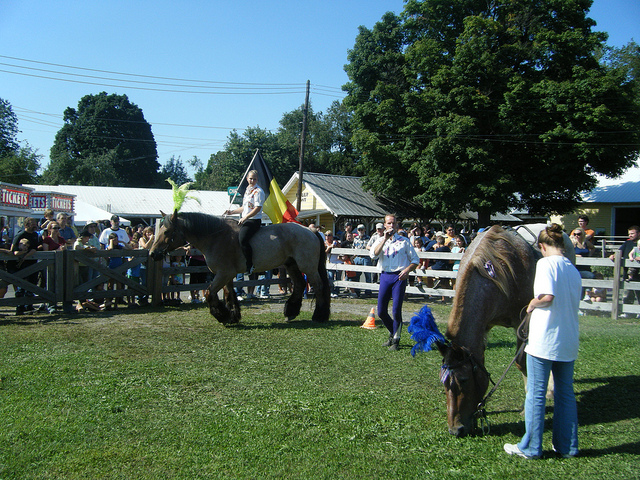Please transcribe the text information in this image. TICKETS LET'S 